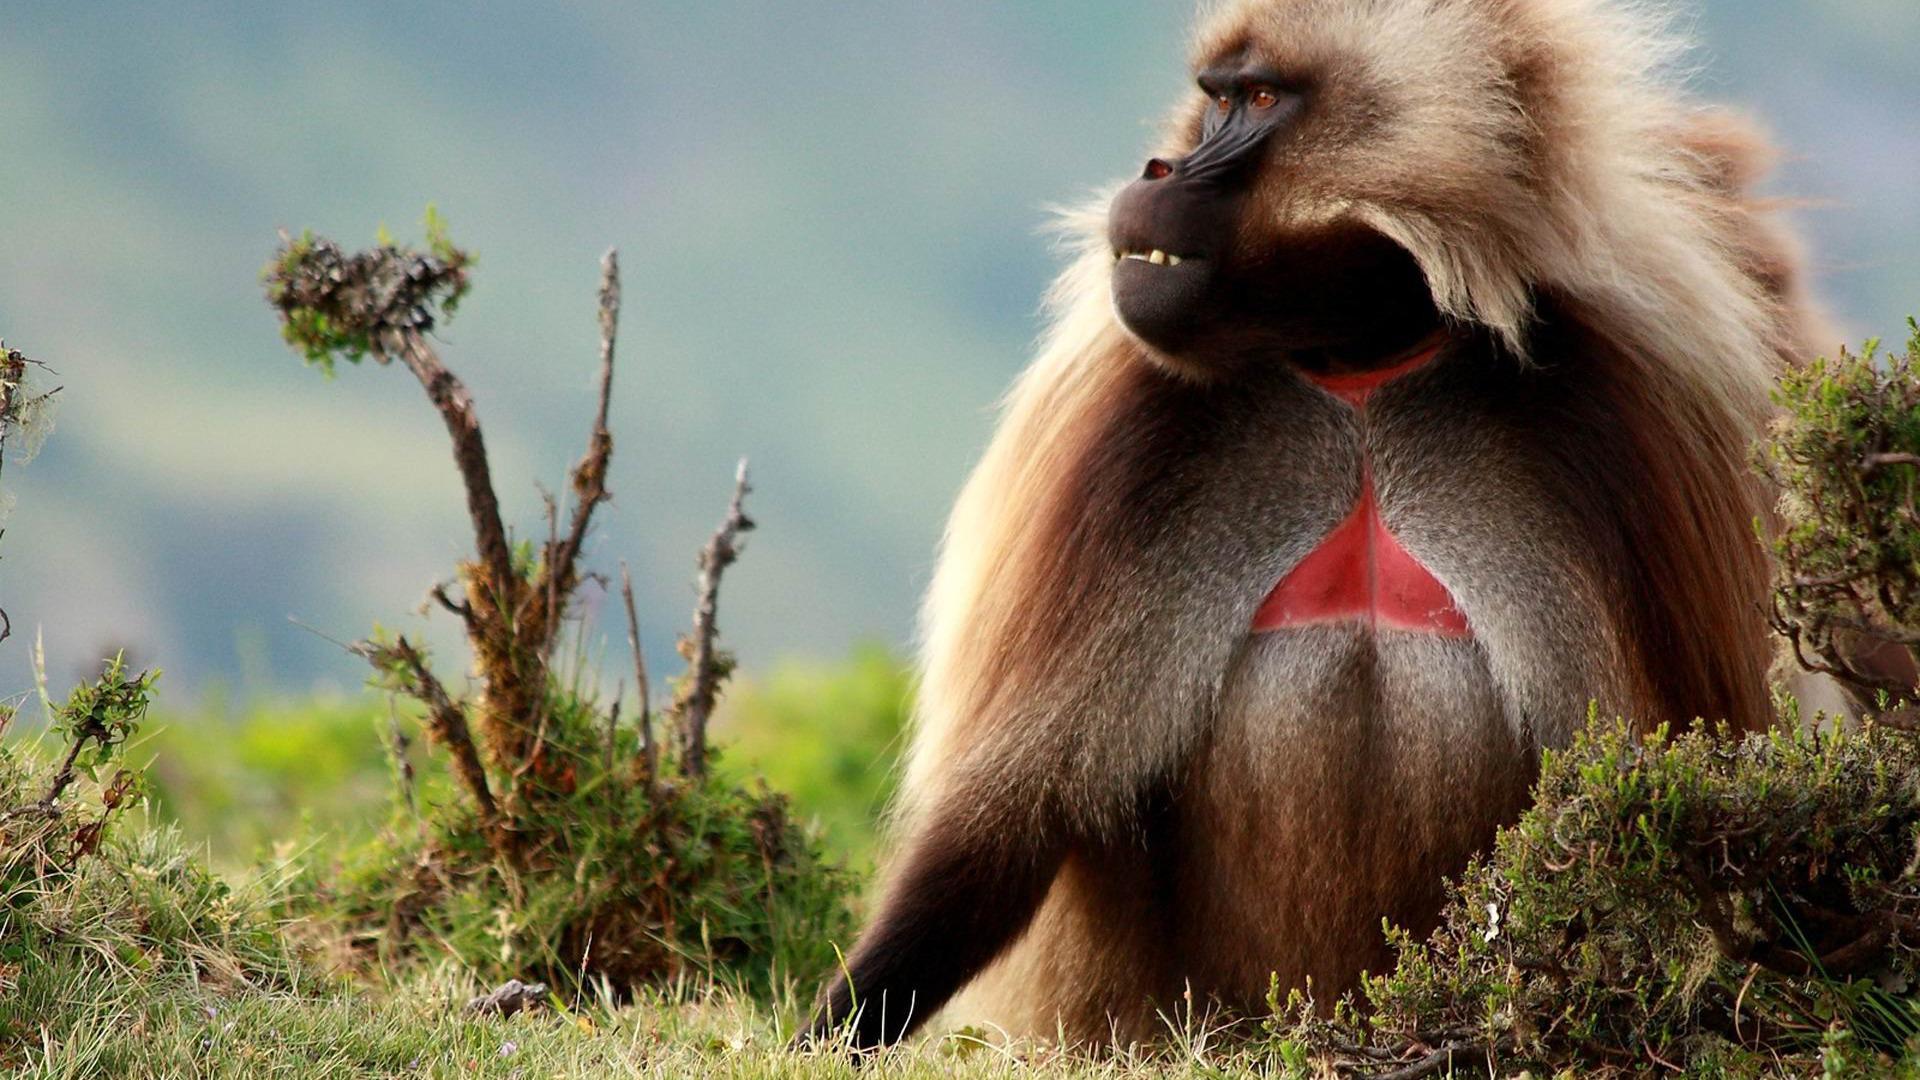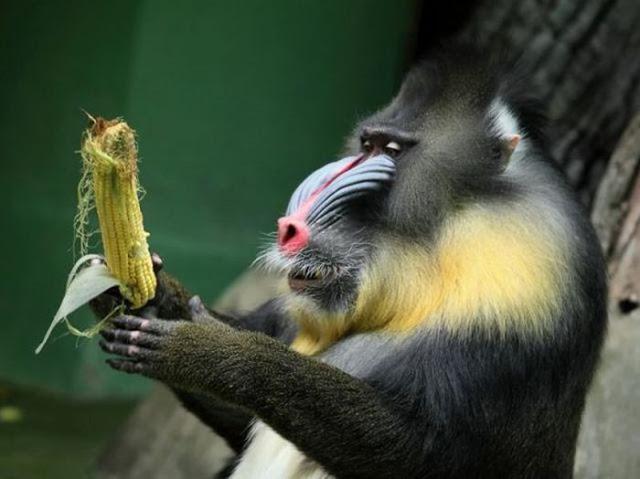The first image is the image on the left, the second image is the image on the right. For the images shown, is this caption "There are exactly two baboons in at least one of the images." true? Answer yes or no. No. The first image is the image on the left, the second image is the image on the right. Examine the images to the left and right. Is the description "The image on the left contains no less than two baboons sitting in a grassy field." accurate? Answer yes or no. No. 